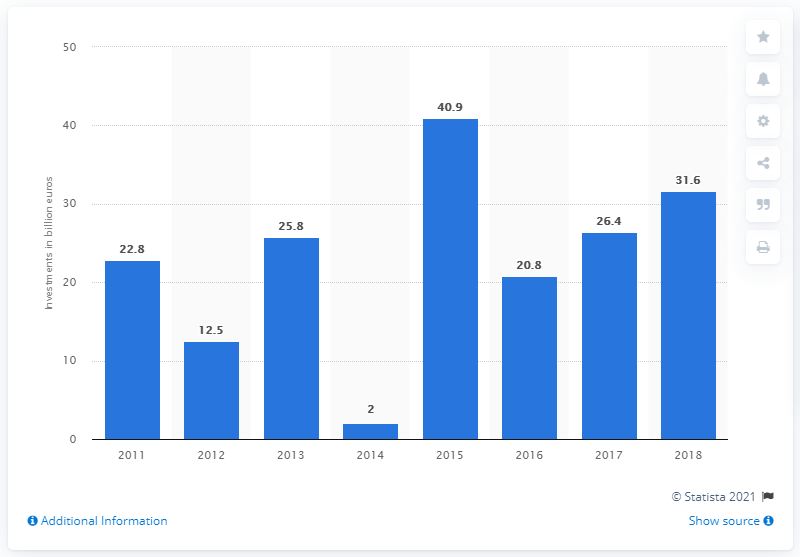Specify some key components in this picture. In 2011, a total of 22.8 billion U.S. dollars was invested in direct investments from abroad. In 2018, a total of 31.6 billion US dollars was invested in France. 